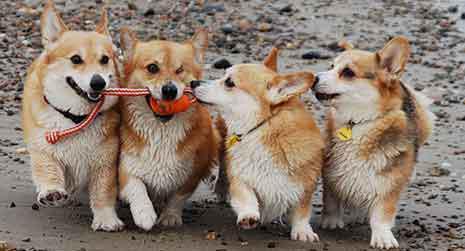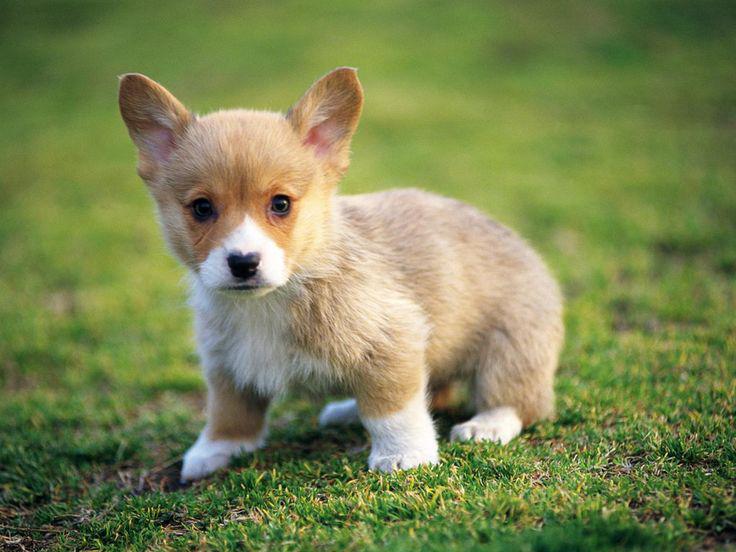The first image is the image on the left, the second image is the image on the right. Examine the images to the left and right. Is the description "In the image on the right, a dog rests among some flowers." accurate? Answer yes or no. No. The first image is the image on the left, the second image is the image on the right. Analyze the images presented: Is the assertion "The image on the right shows a corgi puppy in the middle of a grassy area with flowers." valid? Answer yes or no. No. 